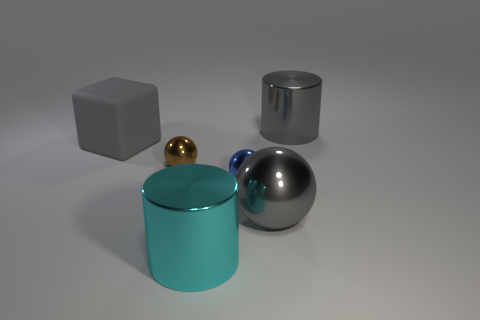Add 4 big red cylinders. How many objects exist? 10 Subtract all blocks. How many objects are left? 5 Subtract all red matte cubes. Subtract all large cyan things. How many objects are left? 5 Add 5 big gray cylinders. How many big gray cylinders are left? 6 Add 6 gray rubber cylinders. How many gray rubber cylinders exist? 6 Subtract 1 gray cubes. How many objects are left? 5 